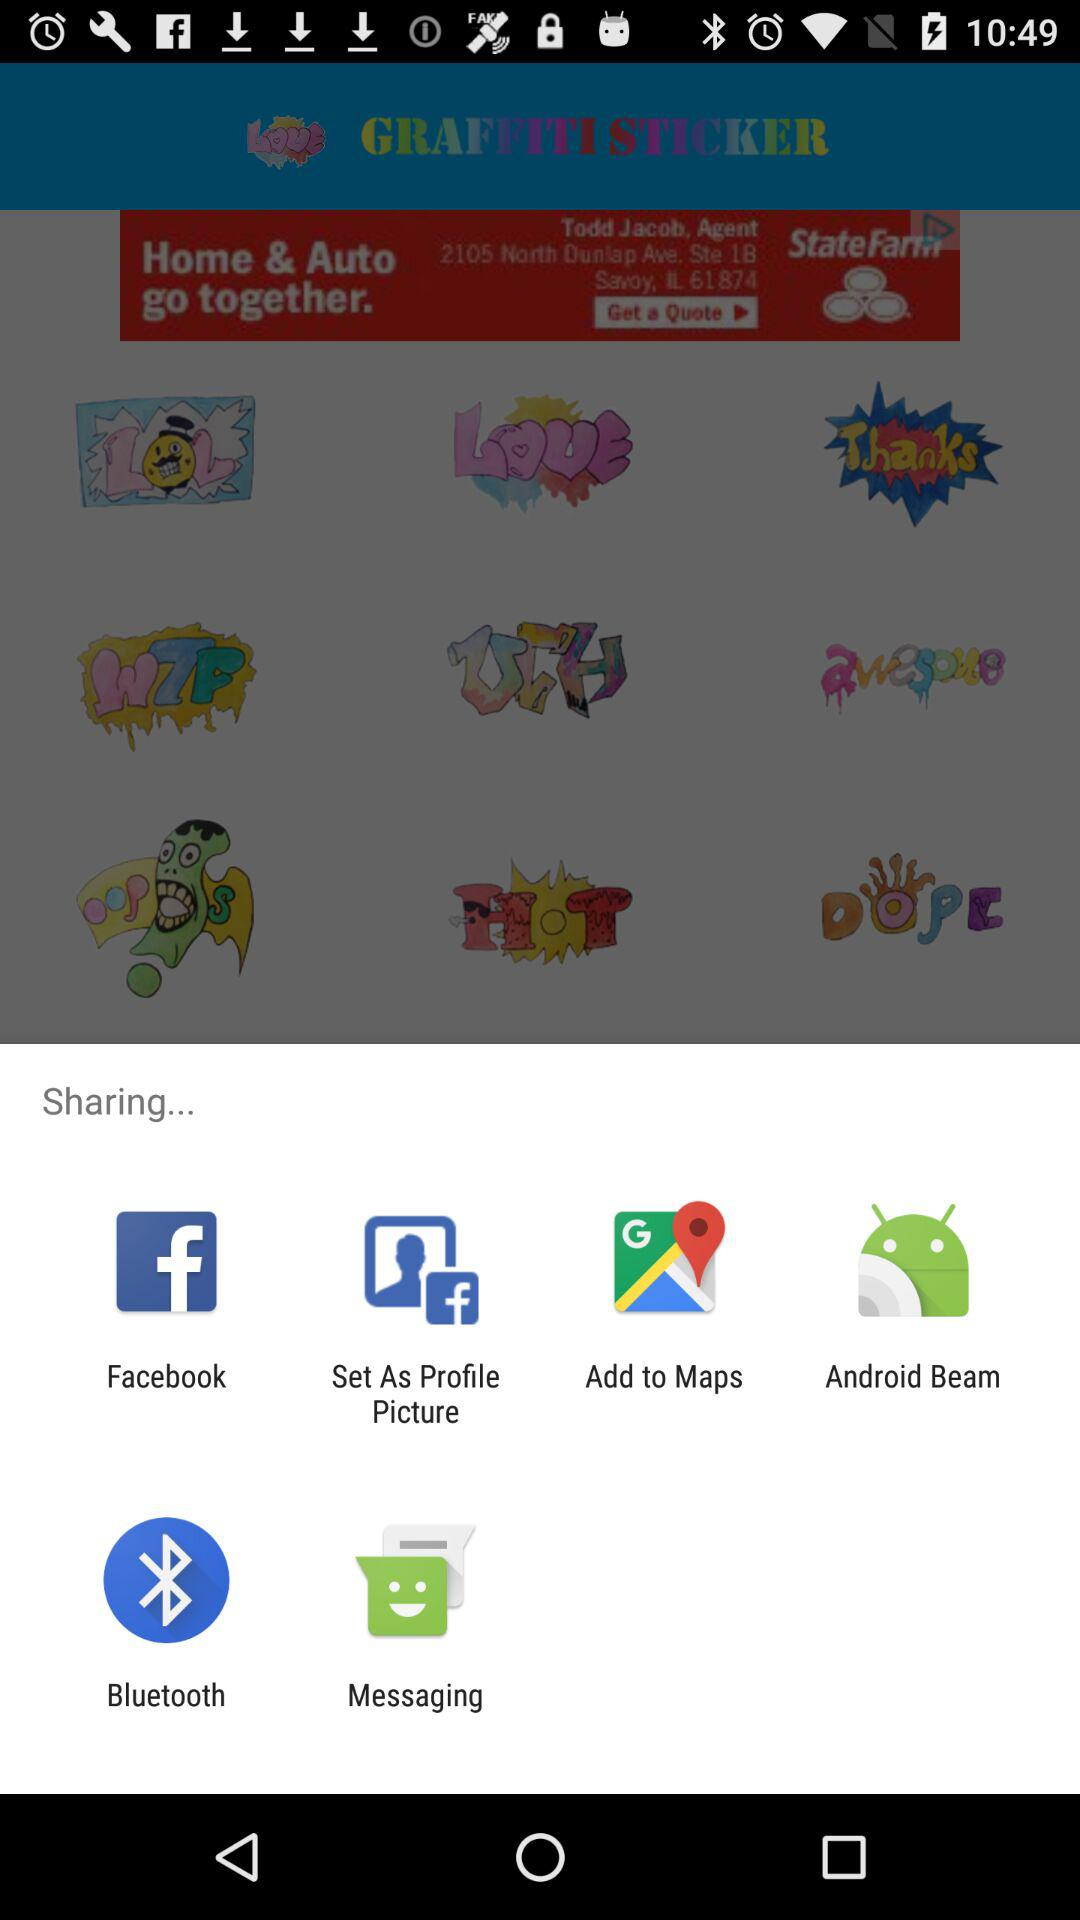What are the sharing options? The sharing options are "Facebook", "Set As Profile Picture", "Add to Maps", "Android Beam", "Bluetooth" and "Messaging". 